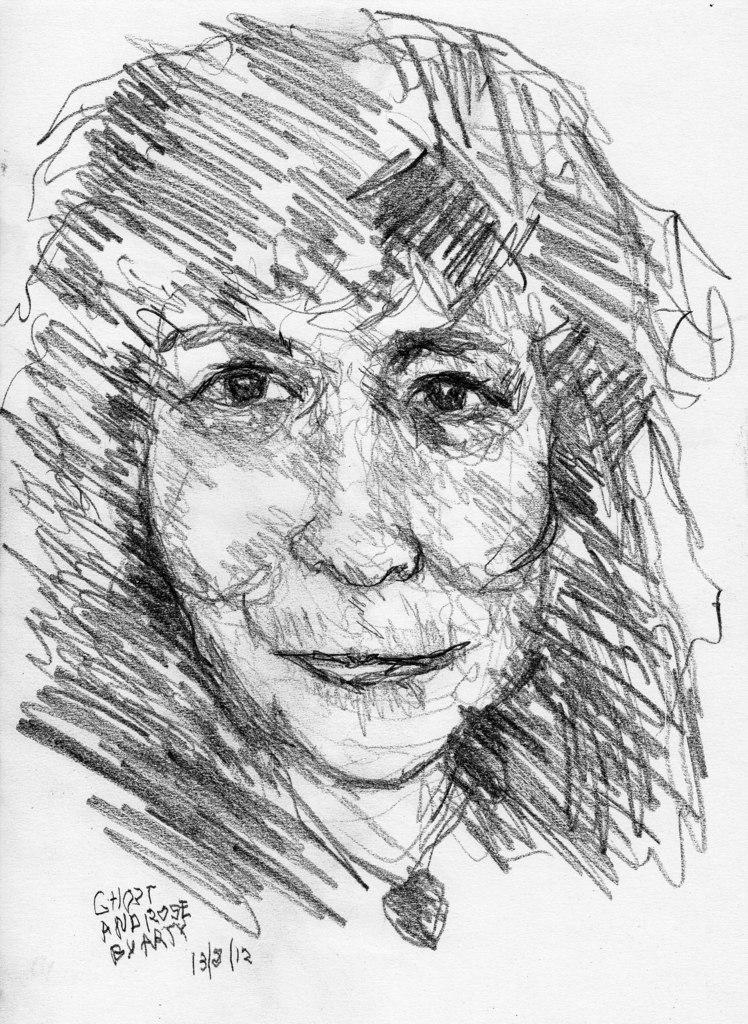What type of art is depicted in the image? The image contains a pencil art of a woman. Can you describe any additional elements in the image? There is text at the bottom left of the image. What type of trousers is the man wearing in the image? There is no man present in the image, only a pencil art of a woman. Can you describe the yak in the image? There is no yak present in the image. 